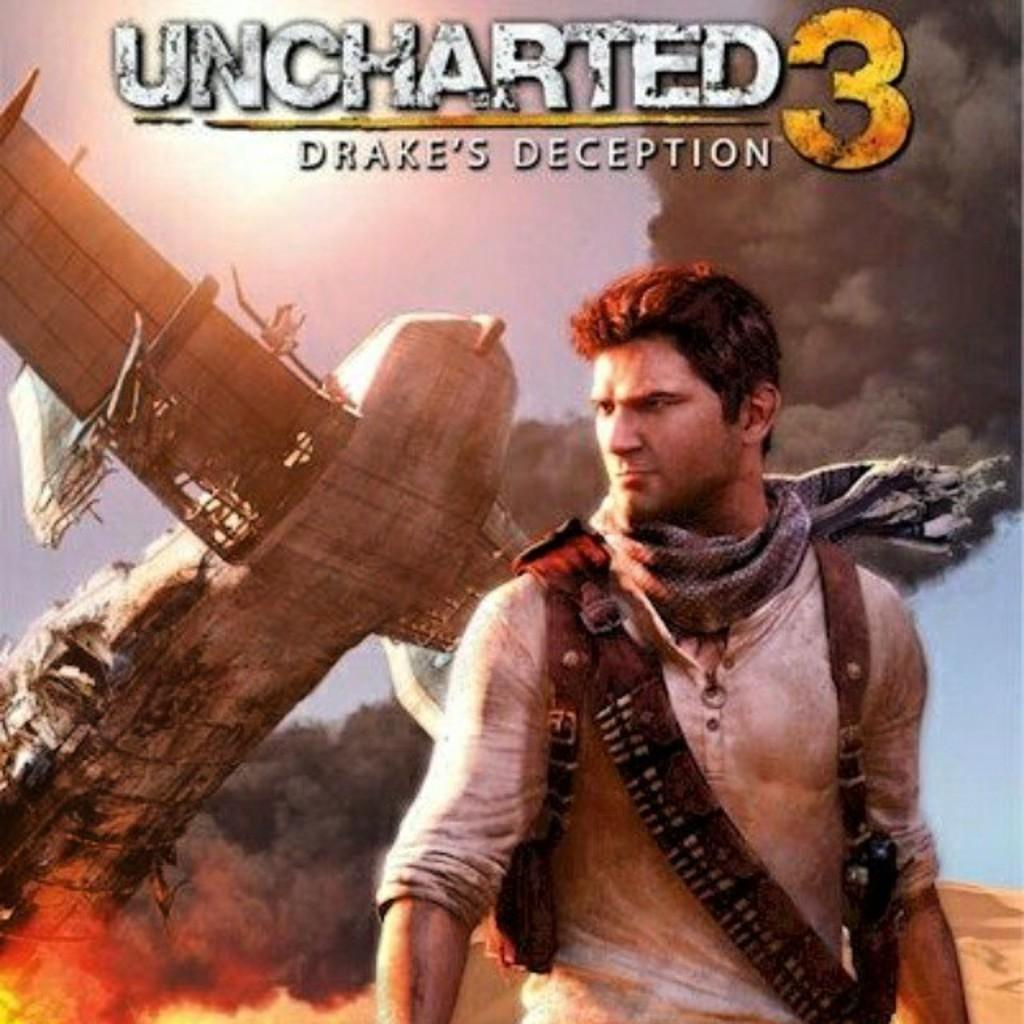<image>
Create a compact narrative representing the image presented. The cover for Uncharted 3 shows an airplane flying above a mans head. 